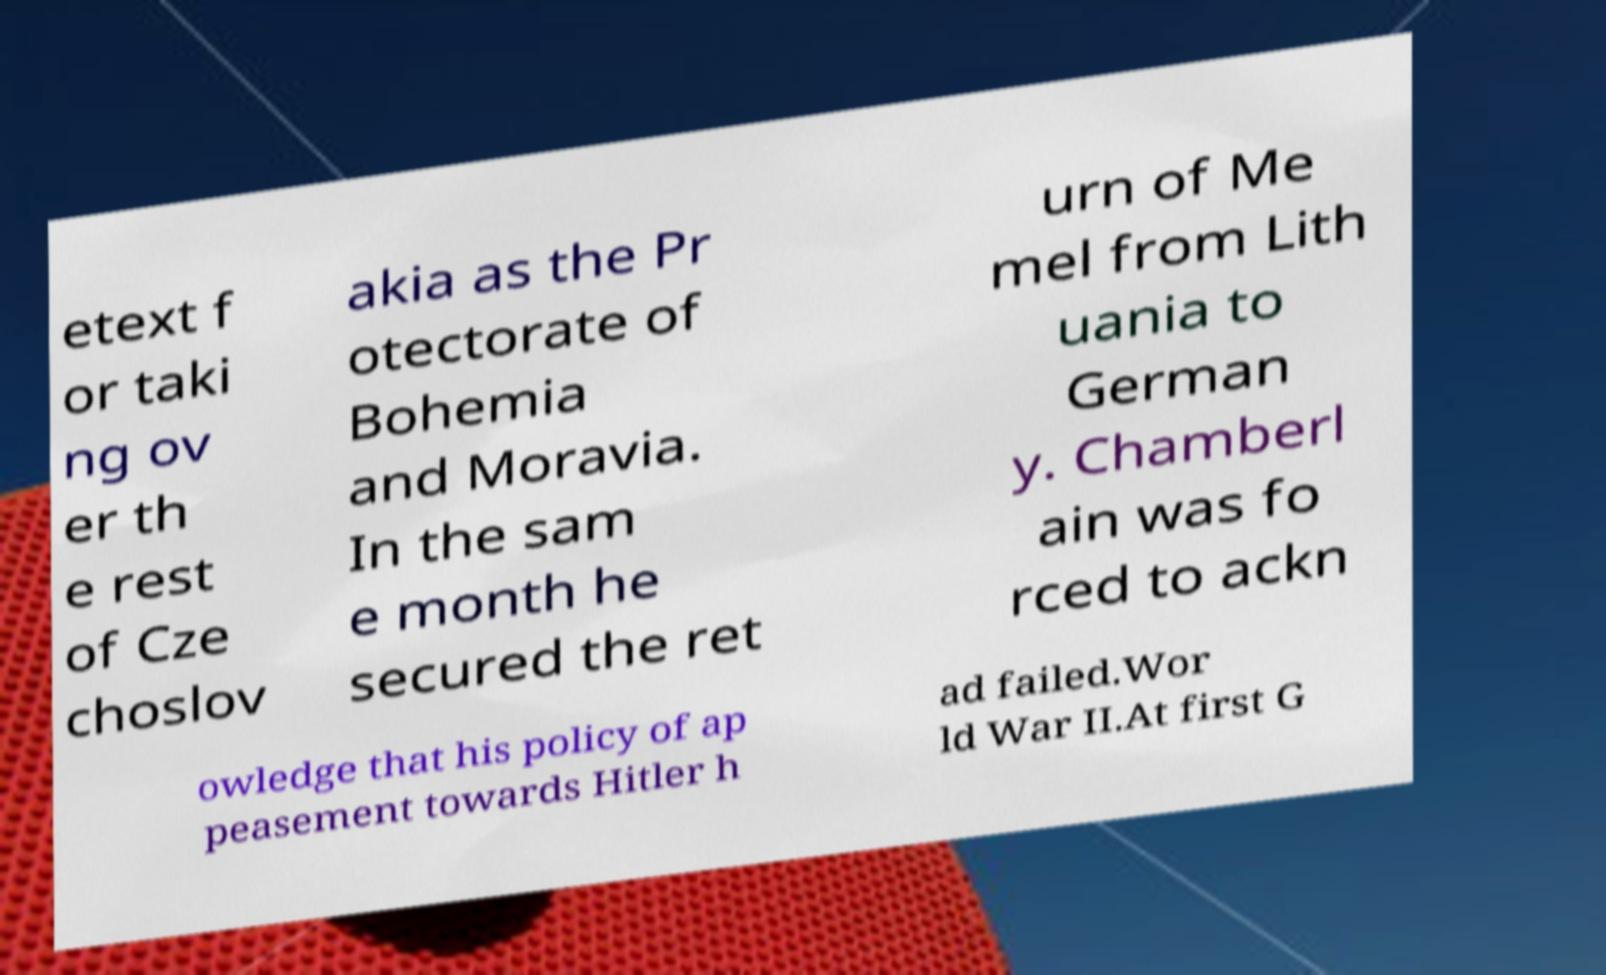Please read and relay the text visible in this image. What does it say? etext f or taki ng ov er th e rest of Cze choslov akia as the Pr otectorate of Bohemia and Moravia. In the sam e month he secured the ret urn of Me mel from Lith uania to German y. Chamberl ain was fo rced to ackn owledge that his policy of ap peasement towards Hitler h ad failed.Wor ld War II.At first G 